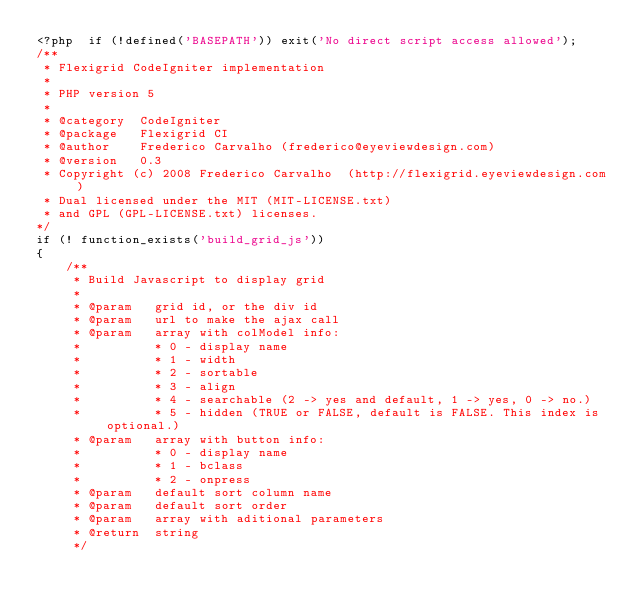<code> <loc_0><loc_0><loc_500><loc_500><_PHP_><?php  if (!defined('BASEPATH')) exit('No direct script access allowed'); 
/**
 * Flexigrid CodeIgniter implementation
 *
 * PHP version 5
 *
 * @category  CodeIgniter
 * @package   Flexigrid CI
 * @author    Frederico Carvalho (frederico@eyeviewdesign.com)
 * @version   0.3
 * Copyright (c) 2008 Frederico Carvalho  (http://flexigrid.eyeviewdesign.com)
 * Dual licensed under the MIT (MIT-LICENSE.txt)
 * and GPL (GPL-LICENSE.txt) licenses.
*/
if (! function_exists('build_grid_js'))
{
	/**
	 * Build Javascript to display grid
	 *
	 * @param	grid id, or the div id
	 * @param	url to make the ajax call
	 * @param	array with colModel info: 		 
	 * 			* 0 - display name
	 *	 		* 1 - width
	 *	 		* 2 - sortable
	 *			* 3 - align
	 * 			* 4 - searchable (2 -> yes and default, 1 -> yes, 0 -> no.)
	 * 			* 5 - hidden (TRUE or FALSE, default is FALSE. This index is optional.) 
	 * @param	array with button info: 	
	 * 		 	* 0 - display name
	 *	 		* 1 - bclass
	 *	 		* 2 - onpress
	 * @param	default sort column name
	 * @param	default sort order
	 * @param	array with aditional parameters
	 * @return	string
	 */</code> 